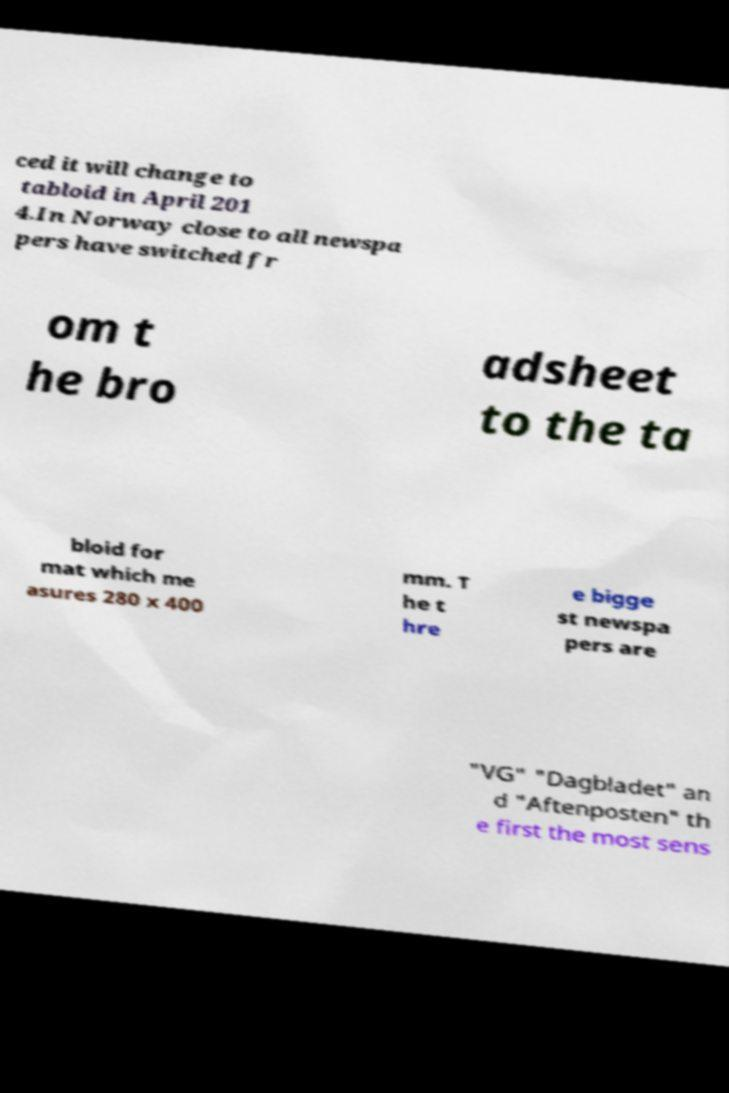Can you read and provide the text displayed in the image?This photo seems to have some interesting text. Can you extract and type it out for me? ced it will change to tabloid in April 201 4.In Norway close to all newspa pers have switched fr om t he bro adsheet to the ta bloid for mat which me asures 280 x 400 mm. T he t hre e bigge st newspa pers are "VG" "Dagbladet" an d "Aftenposten" th e first the most sens 